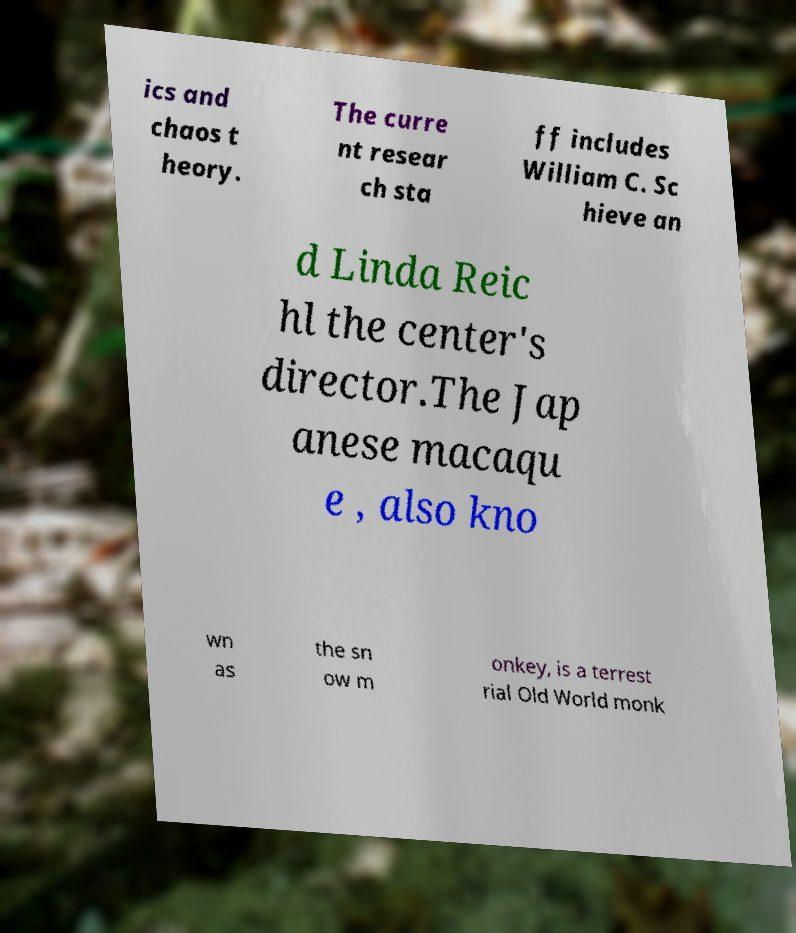Please read and relay the text visible in this image. What does it say? ics and chaos t heory. The curre nt resear ch sta ff includes William C. Sc hieve an d Linda Reic hl the center's director.The Jap anese macaqu e , also kno wn as the sn ow m onkey, is a terrest rial Old World monk 